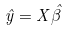<formula> <loc_0><loc_0><loc_500><loc_500>\hat { y } = X \hat { \beta }</formula> 